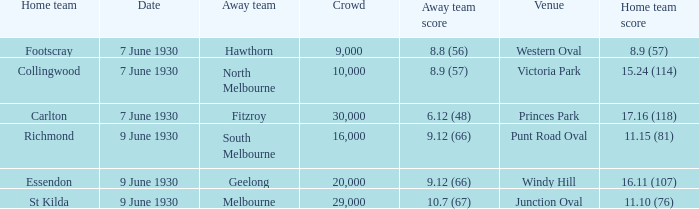7 (67)? 29000.0. 